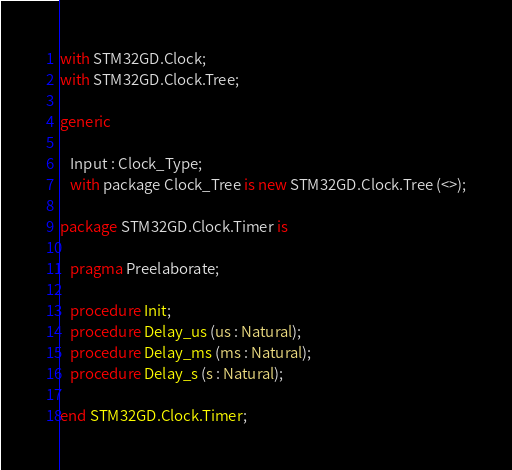<code> <loc_0><loc_0><loc_500><loc_500><_Ada_>with STM32GD.Clock;
with STM32GD.Clock.Tree;

generic

   Input : Clock_Type;
   with package Clock_Tree is new STM32GD.Clock.Tree (<>);

package STM32GD.Clock.Timer is

   pragma Preelaborate;

   procedure Init;
   procedure Delay_us (us : Natural);
   procedure Delay_ms (ms : Natural);
   procedure Delay_s (s : Natural);

end STM32GD.Clock.Timer;
</code> 